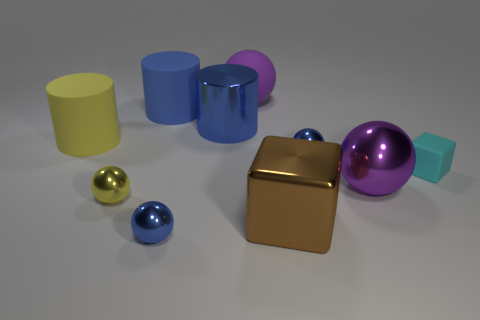Subtract 2 spheres. How many spheres are left? 3 Subtract all cubes. How many objects are left? 8 Add 5 blocks. How many blocks exist? 7 Subtract 0 purple blocks. How many objects are left? 10 Subtract all rubber cylinders. Subtract all big blue metallic cylinders. How many objects are left? 7 Add 5 small cyan blocks. How many small cyan blocks are left? 6 